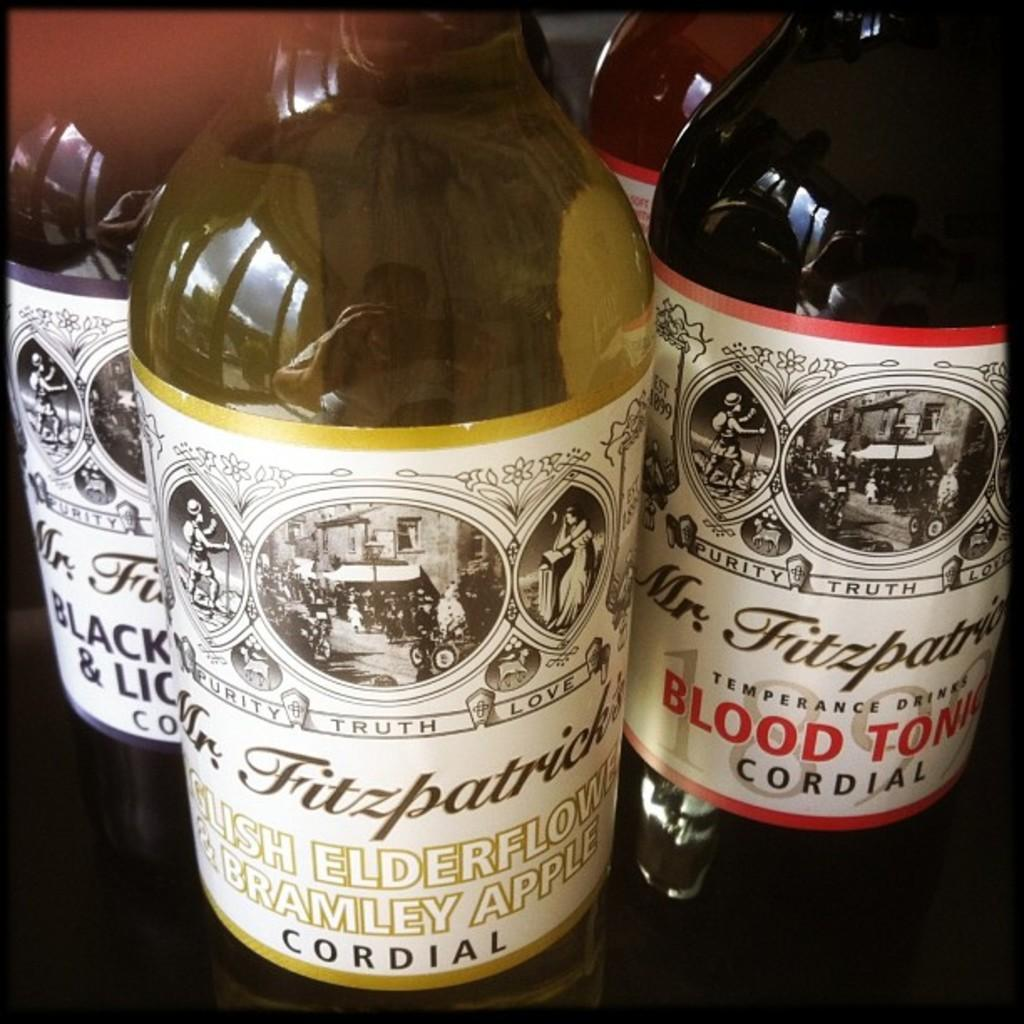<image>
Summarize the visual content of the image. Four bottles of Mr. Fitzpatrick blood tonic cordial. 